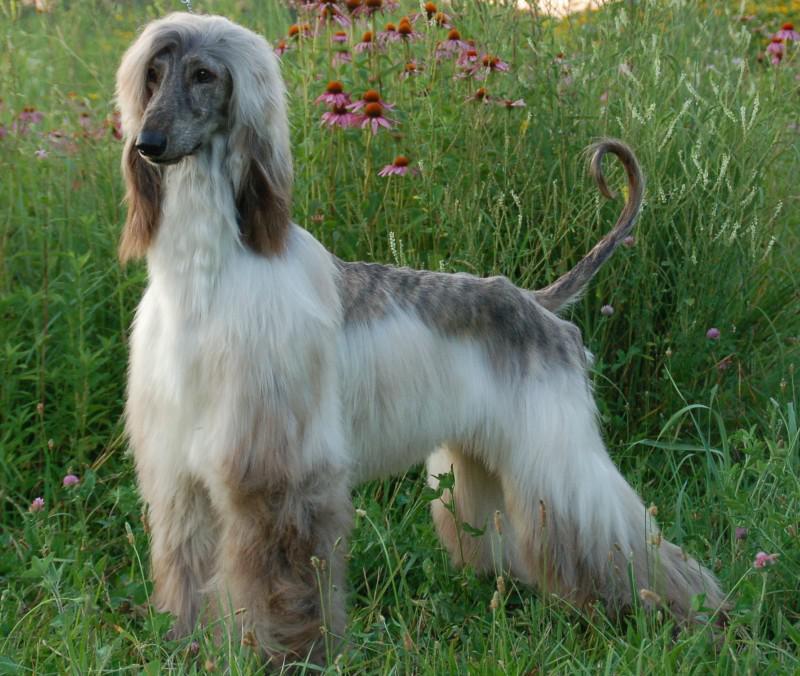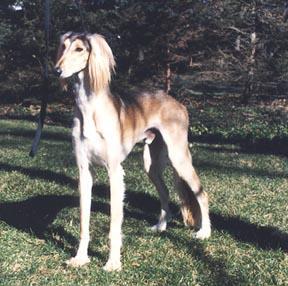The first image is the image on the left, the second image is the image on the right. Analyze the images presented: Is the assertion "One dog's body is turned to the right, and the other dog's body is turned to the left." valid? Answer yes or no. No. The first image is the image on the left, the second image is the image on the right. Given the left and right images, does the statement "The hound on the left is standing and looking forward with its hair combed over one eye, and the hound on the right is standing with its body in profile." hold true? Answer yes or no. No. 